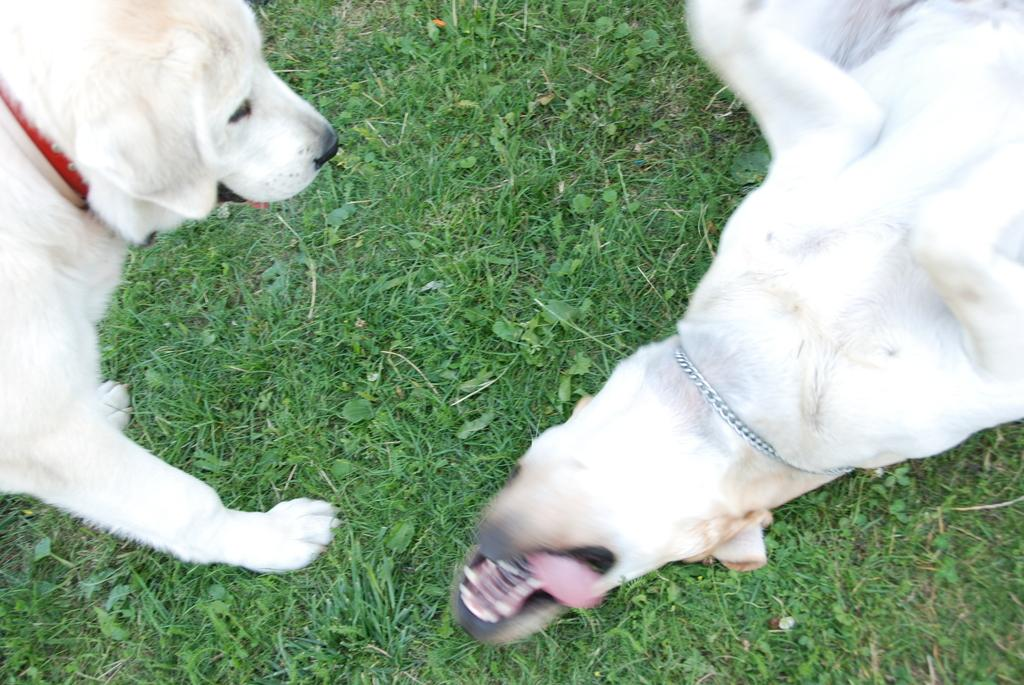How many dogs are in the image? There are two dogs in the image. What color are the dogs? The dogs are white in color. What can be seen in the background of the image? There is grass visible in the background of the image. Can you see any wounds on the dogs in the image? There is no indication of any wounds on the dogs in the image. Are the dogs touching each other in the image? The image does not show whether the dogs are touching each other or not. 